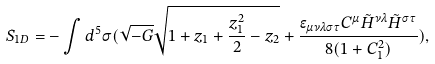Convert formula to latex. <formula><loc_0><loc_0><loc_500><loc_500>S _ { 1 D } = - \int d ^ { 5 } \sigma ( \sqrt { - G } \sqrt { 1 + z _ { 1 } + \frac { z _ { 1 } ^ { 2 } } { 2 } - z _ { 2 } } + \frac { \epsilon _ { \mu \nu \lambda \sigma \tau } C ^ { \mu } \tilde { H } ^ { \nu \lambda } \tilde { H } ^ { \sigma \tau } } { 8 ( 1 + C _ { 1 } ^ { 2 } ) } ) ,</formula> 